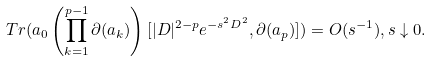<formula> <loc_0><loc_0><loc_500><loc_500>T r ( a _ { 0 } \left ( \prod _ { k = 1 } ^ { p - 1 } \partial ( a _ { k } ) \right ) [ | D | ^ { 2 - p } e ^ { - s ^ { 2 } D ^ { 2 } } , \partial ( a _ { p } ) ] ) = O ( s ^ { - 1 } ) , s \downarrow 0 .</formula> 